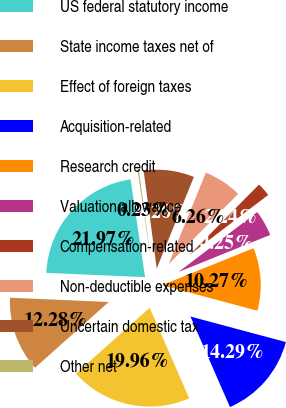<chart> <loc_0><loc_0><loc_500><loc_500><pie_chart><fcel>US federal statutory income<fcel>State income taxes net of<fcel>Effect of foreign taxes<fcel>Acquisition-related<fcel>Research credit<fcel>Valuation allowance<fcel>Compensation-related<fcel>Non-deductible expenses<fcel>Uncertain domestic tax<fcel>Other net<nl><fcel>21.97%<fcel>12.28%<fcel>19.96%<fcel>14.29%<fcel>10.27%<fcel>4.25%<fcel>2.24%<fcel>6.26%<fcel>8.26%<fcel>0.23%<nl></chart> 